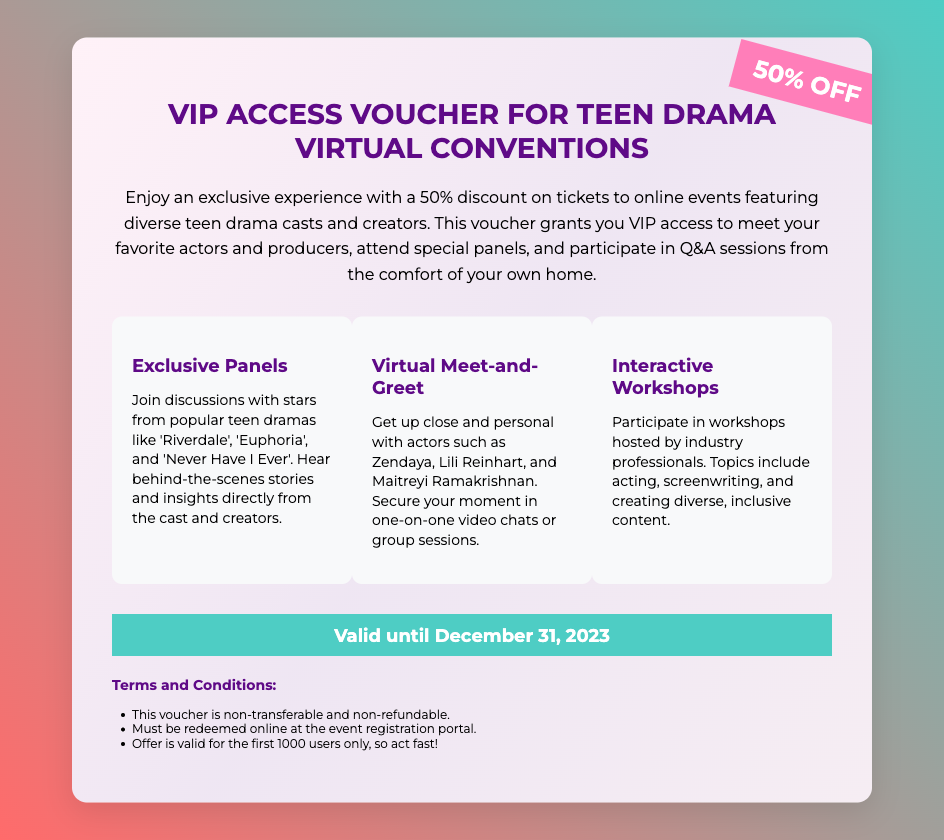what is the discount offered on the voucher? The document states a 50% discount on tickets to online events.
Answer: 50% OFF what is the validity period of the voucher? The voucher is valid until December 31, 2023.
Answer: December 31, 2023 which popular teen drama casts are mentioned for exclusive panels? The document lists 'Riverdale', 'Euphoria', and 'Never Have I Ever' as shows with stars in the panels.
Answer: Riverdale, Euphoria, Never Have I Ever who are some actors you can meet with the voucher? The document mentions Zendaya, Lili Reinhart, and Maitreyi Ramakrishnan as actors available for meet-and-greets.
Answer: Zendaya, Lili Reinhart, Maitreyi Ramakrishnan what type of workshops can participants attend? The voucher allows attendees to participate in workshops on acting, screenwriting, and creating diverse content.
Answer: Acting, screenwriting, and creating diverse content how many users can redeem the voucher offer? According to the terms, the offer is valid for the first 1000 users only.
Answer: 1000 users is the voucher transferable? The terms state that the voucher is non-transferable.
Answer: Non-transferable what is required to redeem the voucher? The voucher must be redeemed online at the event registration portal.
Answer: Online at the event registration portal what is the primary theme of the virtual conventions? The conventions focus on diverse teen drama casts and creators.
Answer: Diversity in teen dramas 